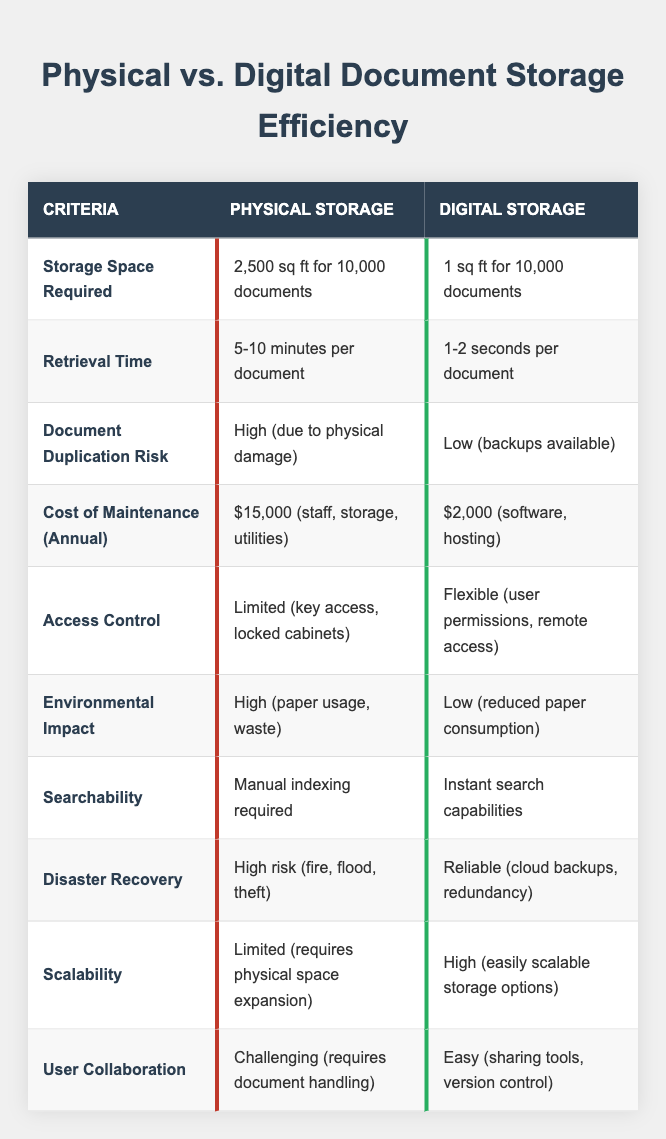What is the storage space required for physical documents? The table states that physical document storage requires 2,500 square feet for 10,000 documents.
Answer: 2,500 sq ft How long does it take to retrieve a physical document? According to the table, it takes 5-10 minutes per document to retrieve physical documents.
Answer: 5-10 minutes What is the annual cost of maintaining digital document storage? The table indicates that the cost of maintaining digital storage annually is $2,000.
Answer: $2,000 Is the document duplication risk higher for physical or digital storage? The table shows that the document duplication risk is high for physical storage and low for digital storage.
Answer: Physical storage What can we say about the environmental impact of digital storage compared to physical storage? The table indicates that physical storage has a high environmental impact due to paper usage, while digital storage has a low impact due to reduced paper consumption.
Answer: Digital storage is low How much less storage space is required for digital documents compared to physical documents? Physical storage requires 2,500 sq ft, while digital requires 1 sq ft. The difference is 2,500 sq ft - 1 sq ft = 2,499 sq ft.
Answer: 2,499 sq ft What retrieval method is needed for searching physical documents? The table specifies that manual indexing is required for physical document retrieval.
Answer: Manual indexing Is there a significant difference in disaster recovery reliability between physical and digital storage? The table indicates that physical storage has a high risk in disaster recovery due to events like fire or flood, whereas digital storage is deemed reliable with cloud backups.
Answer: Yes Which storage type offers the easier user collaboration? According to the table, digital storage is easier for user collaboration due to sharing tools and version control, compared to the challenges in physical storage.
Answer: Digital storage Based on the data, how much more efficient is the retrieval time for digital documents compared to physical documents? Retrieval for physical documents is 5-10 minutes, averaging to 7.5 minutes or 450 seconds. Digital documents take 1-2 seconds, averaging to 1.5 seconds. The difference is 450 seconds - 1.5 seconds = 448.5 seconds.
Answer: 448.5 seconds 